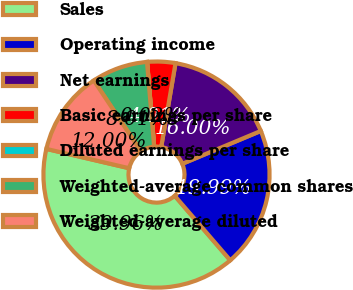Convert chart. <chart><loc_0><loc_0><loc_500><loc_500><pie_chart><fcel>Sales<fcel>Operating income<fcel>Net earnings<fcel>Basic earnings per share<fcel>Diluted earnings per share<fcel>Weighted-average common shares<fcel>Weighted-average diluted<nl><fcel>39.96%<fcel>19.99%<fcel>16.0%<fcel>4.01%<fcel>0.02%<fcel>8.01%<fcel>12.0%<nl></chart> 